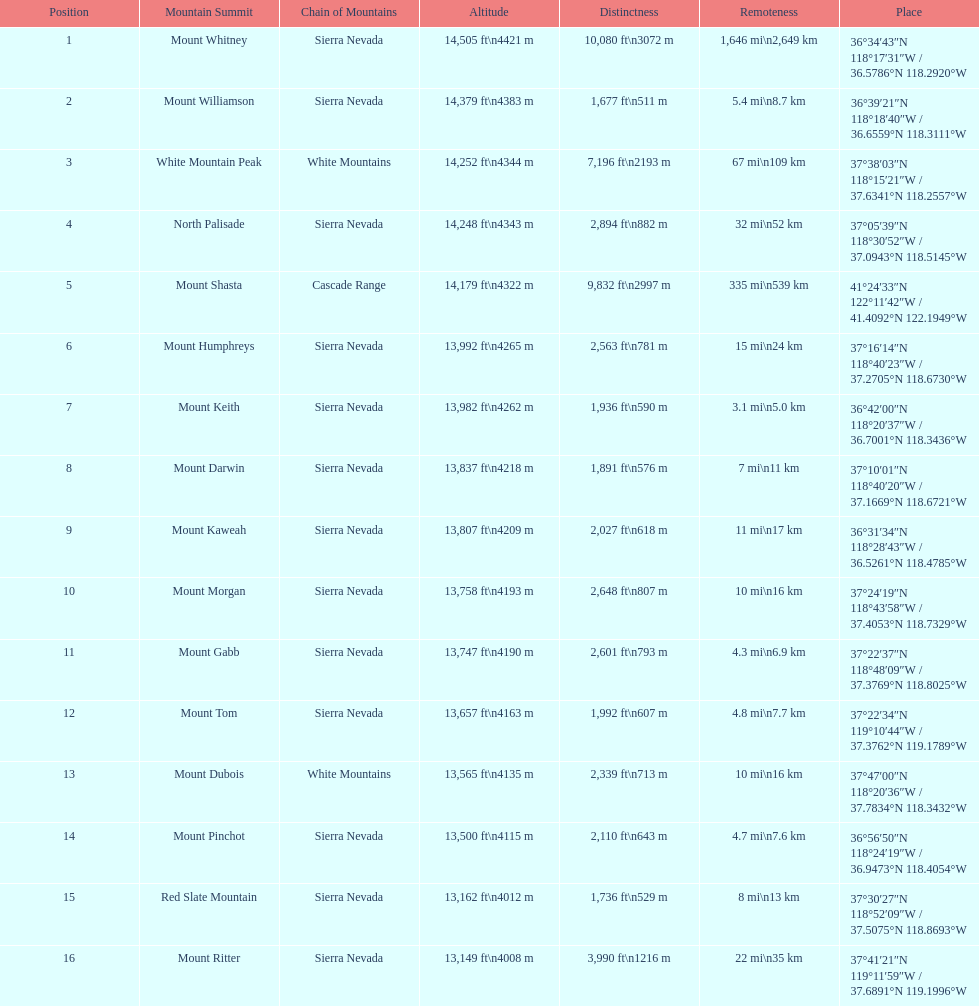What is the next highest mountain peak after north palisade? Mount Shasta. 